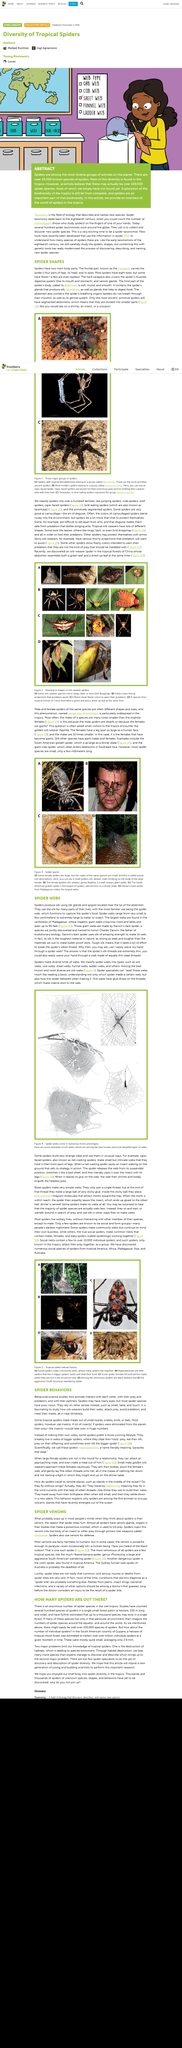Specify some key components in this picture. There are several types of spider webs, which can be classified based on their structure and design. Orb webs, cob webs, sheer webs, funnel webs, ladder webs, and others are some of the types of spider webs that have been identified. Each type of spider web is unique in its own way and serves a specific purpose in the spider's survival and reproduction. The characteristics of each type of spider web, such as the shape, size, and design, distinguish one type from another. The majority of spiders are solitary creatures. According to the article, some spiders are exceptionally skilled at the art of disguise and camouflage. The largest spider webs are found in the rainforests of Madagascar, where they can span over 90 feet and criss cross over rivers and lakes. These majestic webs are created by spiders that live in these areas. A recent discovery in the tropical forests of China has revealed the existence of an orb-weaver spider, according to the article. 